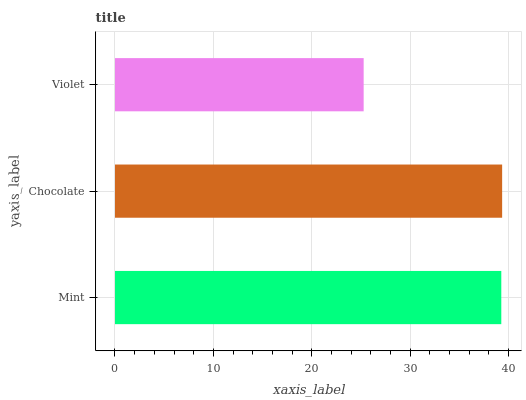Is Violet the minimum?
Answer yes or no. Yes. Is Chocolate the maximum?
Answer yes or no. Yes. Is Chocolate the minimum?
Answer yes or no. No. Is Violet the maximum?
Answer yes or no. No. Is Chocolate greater than Violet?
Answer yes or no. Yes. Is Violet less than Chocolate?
Answer yes or no. Yes. Is Violet greater than Chocolate?
Answer yes or no. No. Is Chocolate less than Violet?
Answer yes or no. No. Is Mint the high median?
Answer yes or no. Yes. Is Mint the low median?
Answer yes or no. Yes. Is Violet the high median?
Answer yes or no. No. Is Violet the low median?
Answer yes or no. No. 